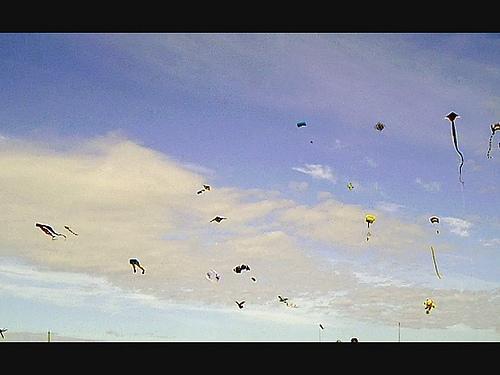How many people are in the picture?
Give a very brief answer. 0. 